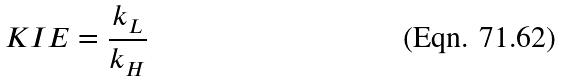<formula> <loc_0><loc_0><loc_500><loc_500>K I E = \frac { k _ { L } } { k _ { H } }</formula> 